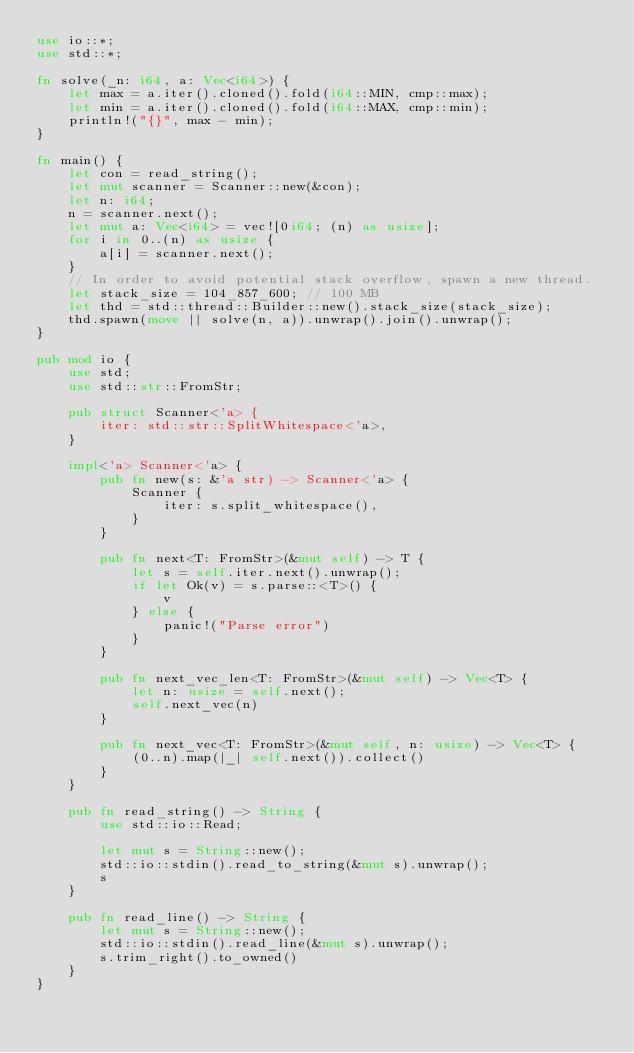<code> <loc_0><loc_0><loc_500><loc_500><_Rust_>use io::*;
use std::*;

fn solve(_n: i64, a: Vec<i64>) {
    let max = a.iter().cloned().fold(i64::MIN, cmp::max);
    let min = a.iter().cloned().fold(i64::MAX, cmp::min);
    println!("{}", max - min);
}

fn main() {
    let con = read_string();
    let mut scanner = Scanner::new(&con);
    let n: i64;
    n = scanner.next();
    let mut a: Vec<i64> = vec![0i64; (n) as usize];
    for i in 0..(n) as usize {
        a[i] = scanner.next();
    }
    // In order to avoid potential stack overflow, spawn a new thread.
    let stack_size = 104_857_600; // 100 MB
    let thd = std::thread::Builder::new().stack_size(stack_size);
    thd.spawn(move || solve(n, a)).unwrap().join().unwrap();
}

pub mod io {
    use std;
    use std::str::FromStr;

    pub struct Scanner<'a> {
        iter: std::str::SplitWhitespace<'a>,
    }

    impl<'a> Scanner<'a> {
        pub fn new(s: &'a str) -> Scanner<'a> {
            Scanner {
                iter: s.split_whitespace(),
            }
        }

        pub fn next<T: FromStr>(&mut self) -> T {
            let s = self.iter.next().unwrap();
            if let Ok(v) = s.parse::<T>() {
                v
            } else {
                panic!("Parse error")
            }
        }

        pub fn next_vec_len<T: FromStr>(&mut self) -> Vec<T> {
            let n: usize = self.next();
            self.next_vec(n)
        }

        pub fn next_vec<T: FromStr>(&mut self, n: usize) -> Vec<T> {
            (0..n).map(|_| self.next()).collect()
        }
    }

    pub fn read_string() -> String {
        use std::io::Read;

        let mut s = String::new();
        std::io::stdin().read_to_string(&mut s).unwrap();
        s
    }

    pub fn read_line() -> String {
        let mut s = String::new();
        std::io::stdin().read_line(&mut s).unwrap();
        s.trim_right().to_owned()
    }
}
</code> 